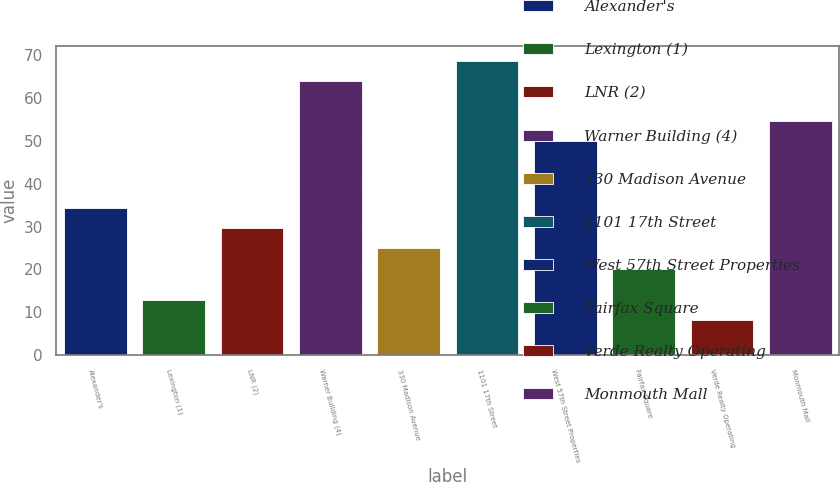Convert chart. <chart><loc_0><loc_0><loc_500><loc_500><bar_chart><fcel>Alexander's<fcel>Lexington (1)<fcel>LNR (2)<fcel>Warner Building (4)<fcel>330 Madison Avenue<fcel>1101 17th Street<fcel>West 57th Street Properties<fcel>Fairfax Square<fcel>Verde Realty Operating<fcel>Monmouth Mall<nl><fcel>34.34<fcel>12.97<fcel>29.67<fcel>64.01<fcel>25<fcel>68.68<fcel>50<fcel>20<fcel>8.3<fcel>54.67<nl></chart> 